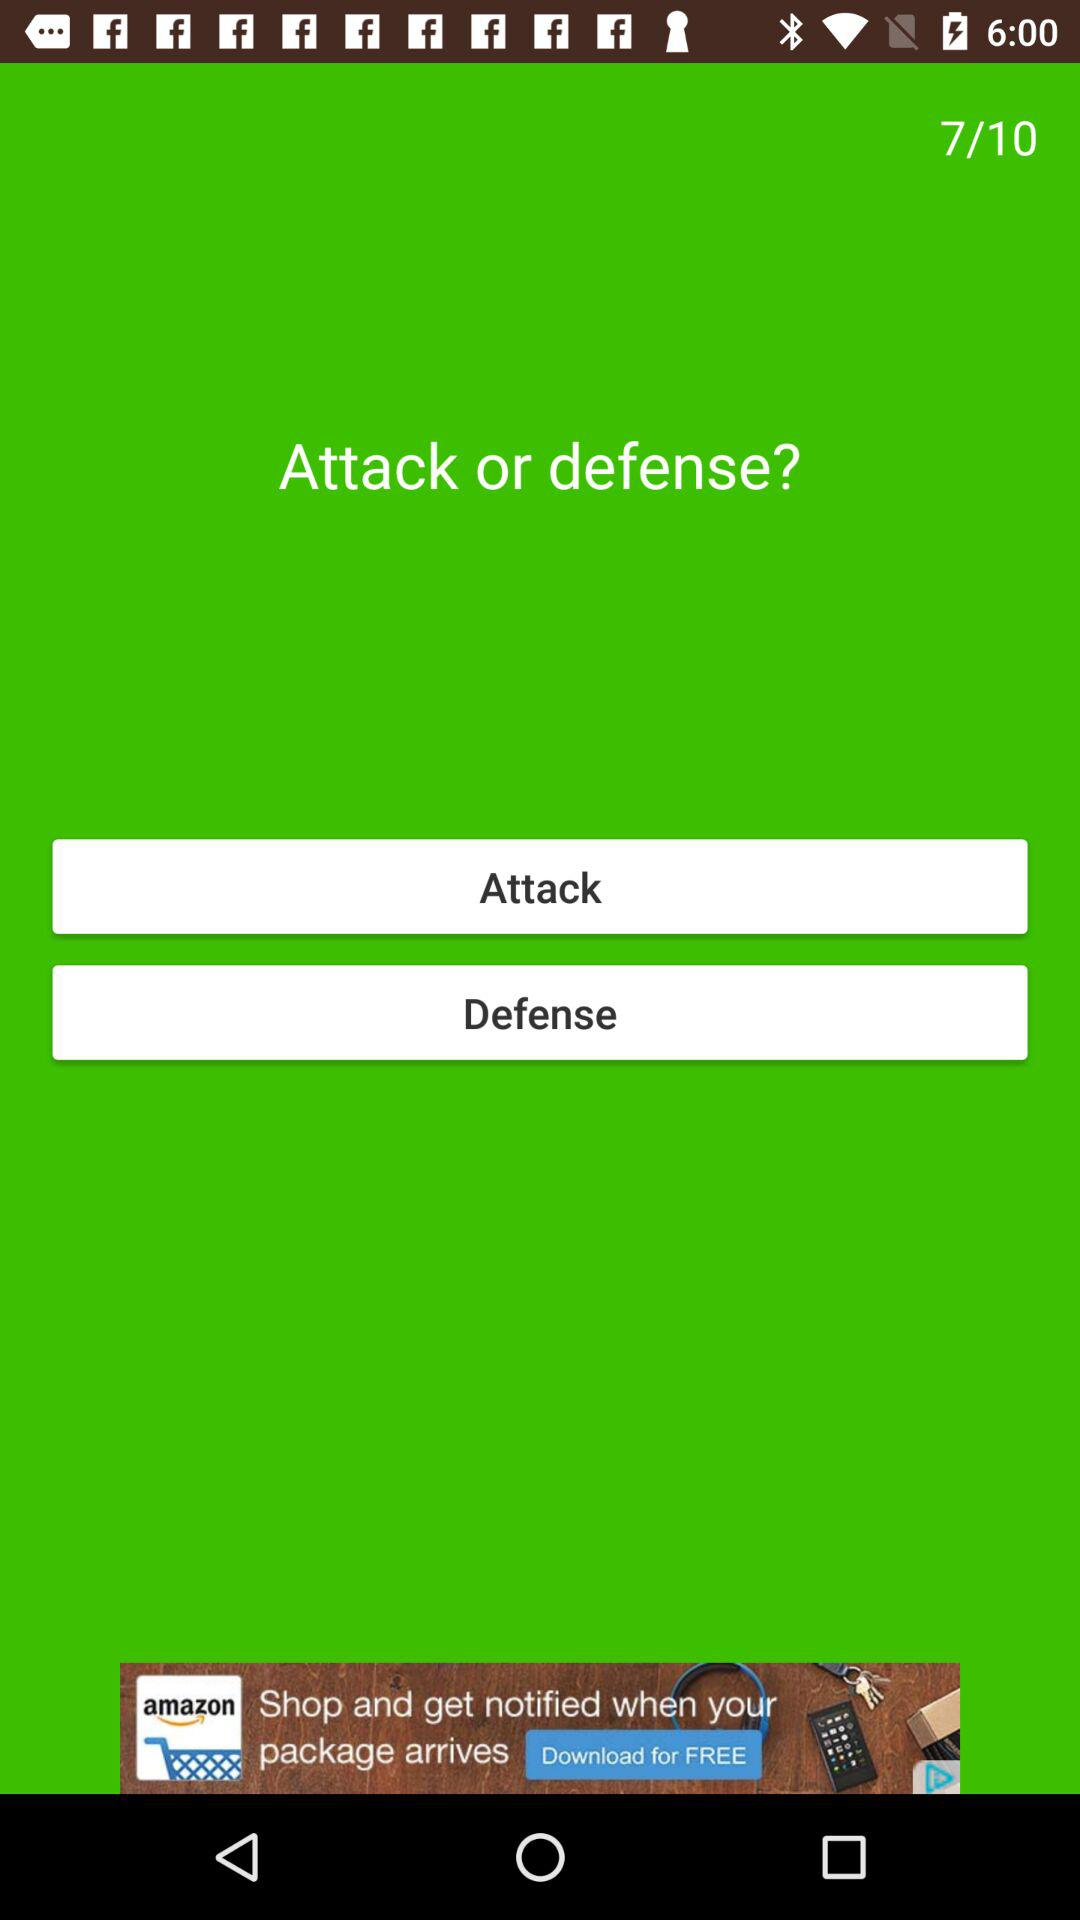What question am I asking? You are asking "Attack or defense?". 